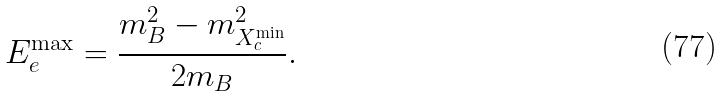Convert formula to latex. <formula><loc_0><loc_0><loc_500><loc_500>E _ { e } ^ { \max } = \frac { m _ { B } ^ { 2 } - m ^ { 2 } _ { X _ { c } ^ { \min } } } { 2 m _ { B } } .</formula> 